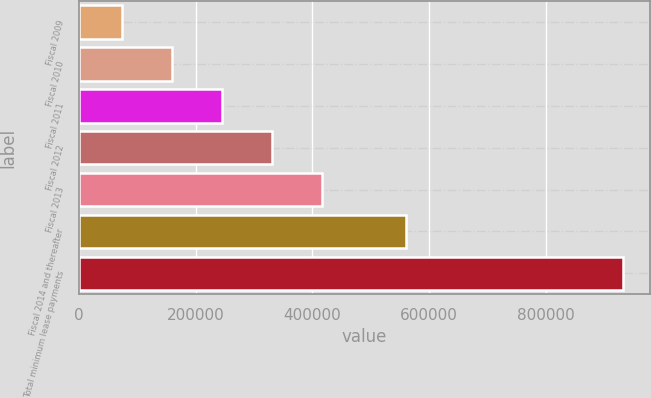<chart> <loc_0><loc_0><loc_500><loc_500><bar_chart><fcel>Fiscal 2009<fcel>Fiscal 2010<fcel>Fiscal 2011<fcel>Fiscal 2012<fcel>Fiscal 2013<fcel>Fiscal 2014 and thereafter<fcel>Total minimum lease payments<nl><fcel>73542<fcel>159361<fcel>245180<fcel>330999<fcel>416818<fcel>561040<fcel>931732<nl></chart> 